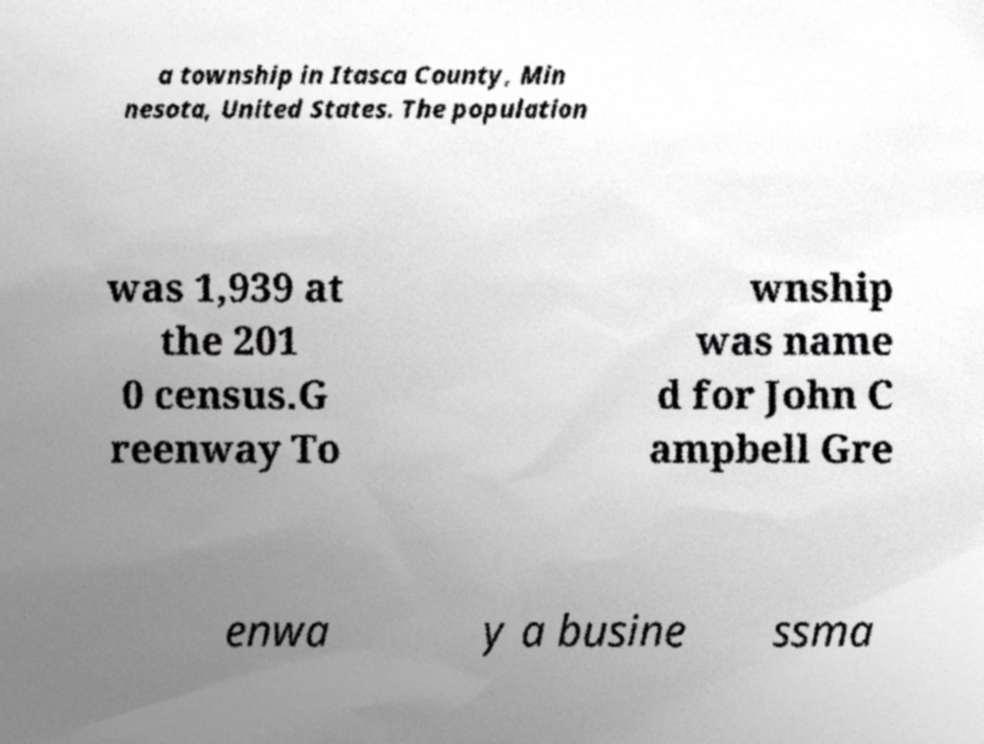Please read and relay the text visible in this image. What does it say? a township in Itasca County, Min nesota, United States. The population was 1,939 at the 201 0 census.G reenway To wnship was name d for John C ampbell Gre enwa y a busine ssma 